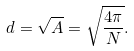<formula> <loc_0><loc_0><loc_500><loc_500>d = \sqrt { A } = \sqrt { \frac { 4 \pi } { N } } .</formula> 